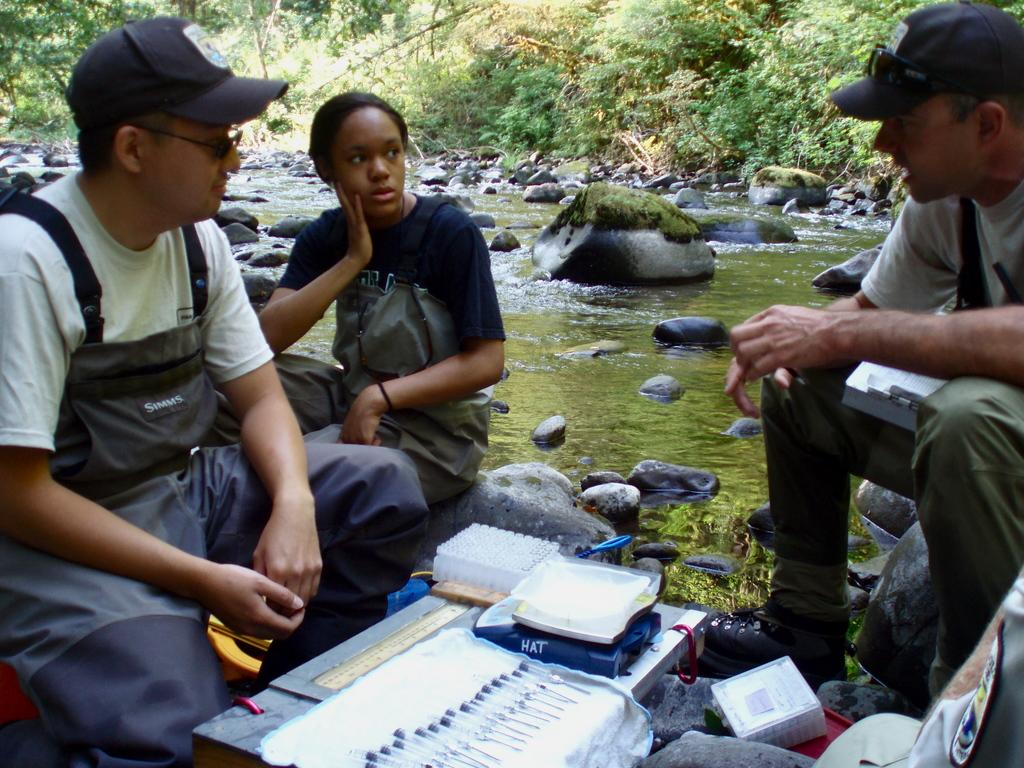What are the people in the image doing? The people in the image are sitting. What can be seen on the table in the image? There are medical devices on a table in the image. What is visible in the background of the image? There is water, stones, trees, and plants visible in the image. What color are the eyes of the iron in the image? There is no iron present in the image, and therefore no eyes to describe. 